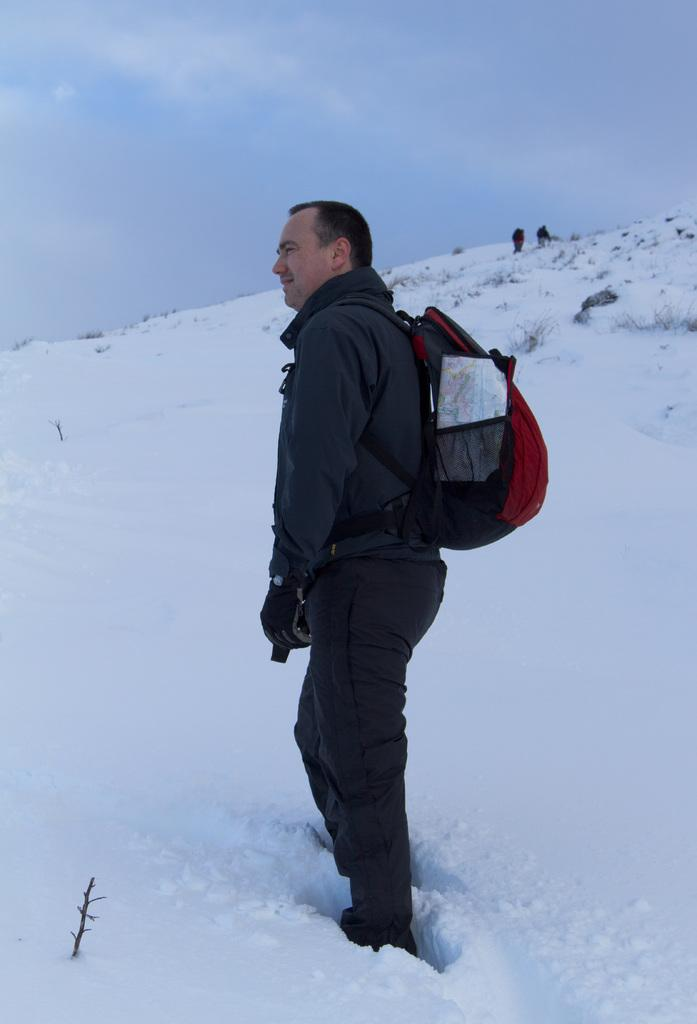What is the main subject of the image? There is a person standing in the image. What is the person wearing? The person is wearing a bag. What type of vegetation can be seen in the image? There is dry grass visible in the image. What is the weather like in the image? There is snow in the image, indicating a cold climate. How many people are present in the image? There are other people in the image, in addition to the main subject. What is the color of the sky in the image? The sky is blue and white in color. How many chickens are visible in the image? There are no chickens present in the image. What type of nut is being cracked by the person in the image? There is no nut being cracked in the image; the person is simply standing. 